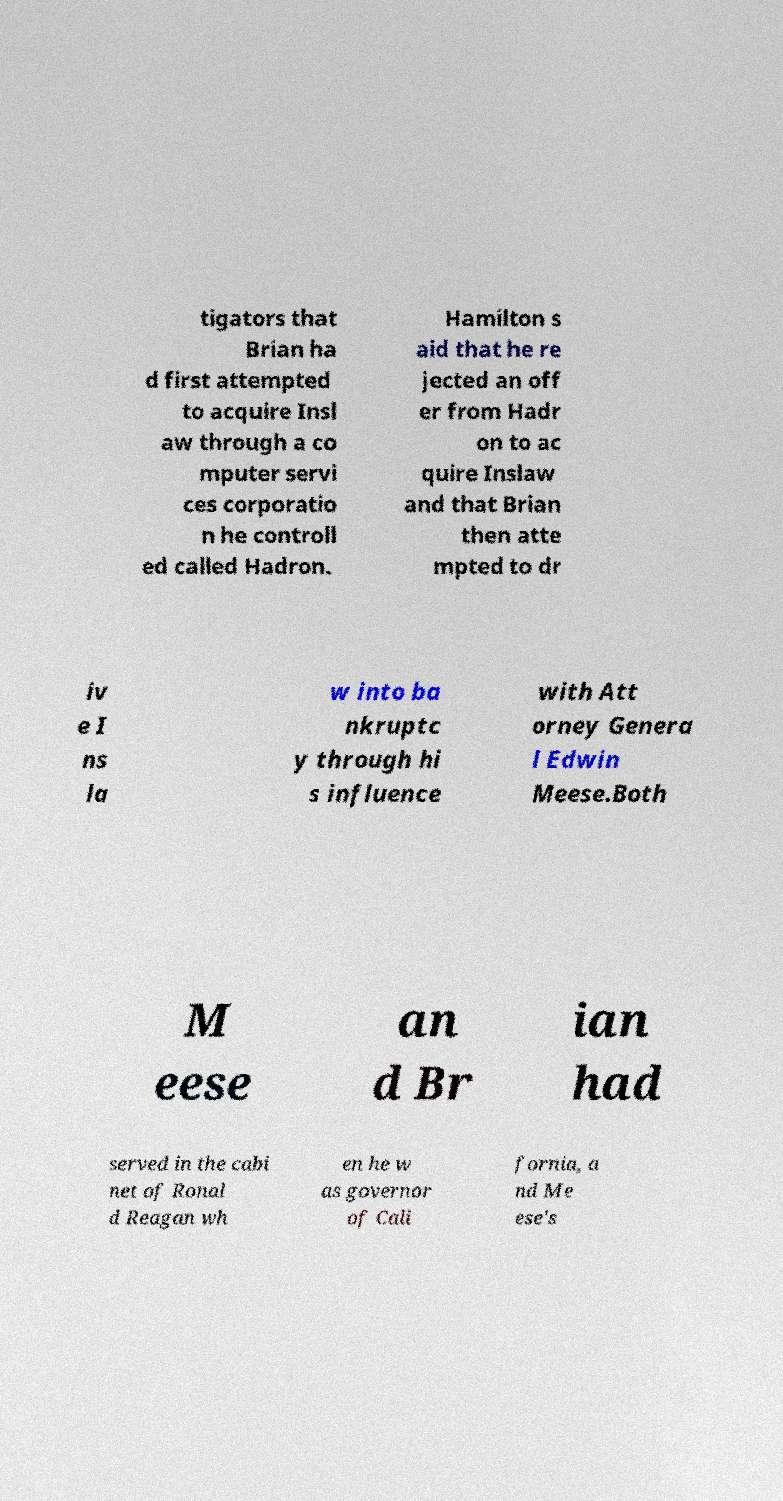For documentation purposes, I need the text within this image transcribed. Could you provide that? tigators that Brian ha d first attempted to acquire Insl aw through a co mputer servi ces corporatio n he controll ed called Hadron. Hamilton s aid that he re jected an off er from Hadr on to ac quire Inslaw and that Brian then atte mpted to dr iv e I ns la w into ba nkruptc y through hi s influence with Att orney Genera l Edwin Meese.Both M eese an d Br ian had served in the cabi net of Ronal d Reagan wh en he w as governor of Cali fornia, a nd Me ese's 